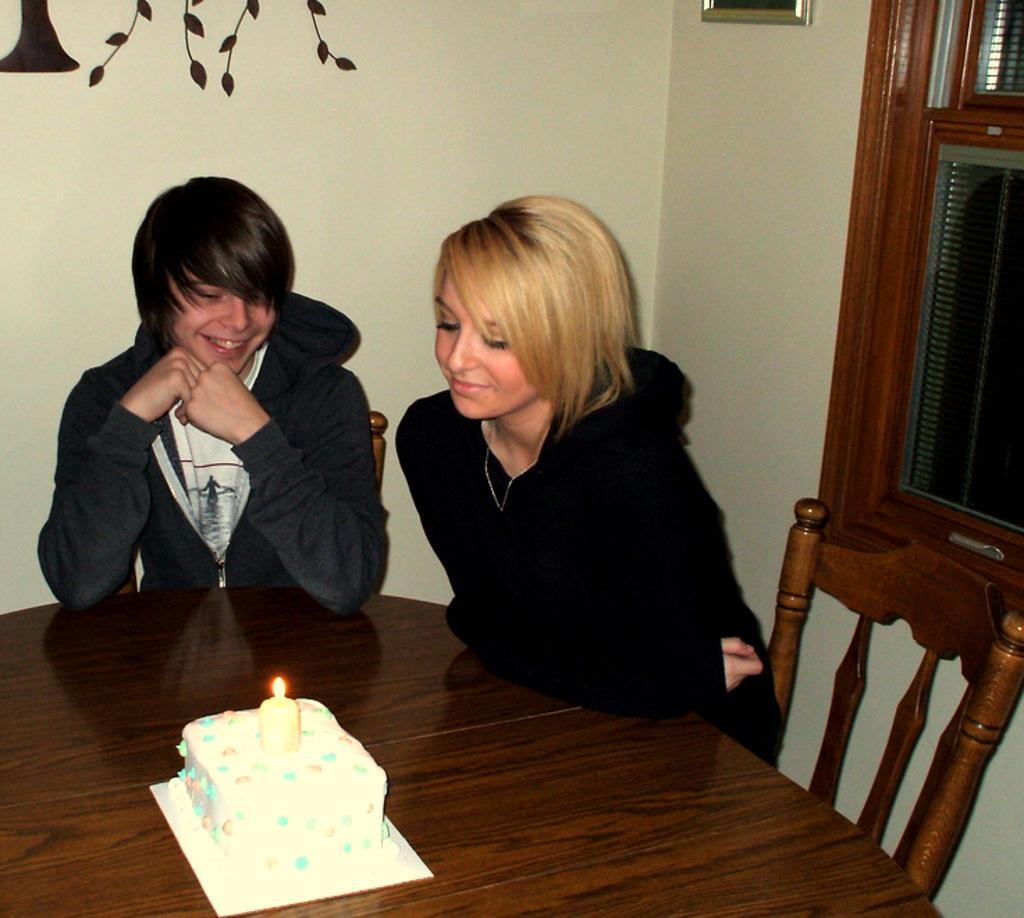Can you describe this image briefly? In this image on the right side there is one woman who is sitting and smiling. On the left side there is one man who is sitting and smiling in front of them there is one table. On that table there is one cake and candle, on the background there is one wall on the top of the right corner there is one window and one photo frame is there. 